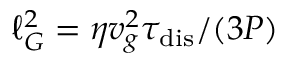Convert formula to latex. <formula><loc_0><loc_0><loc_500><loc_500>\ell _ { G } ^ { 2 } = \eta v _ { g } ^ { 2 } \tau _ { d i s } / ( 3 P )</formula> 